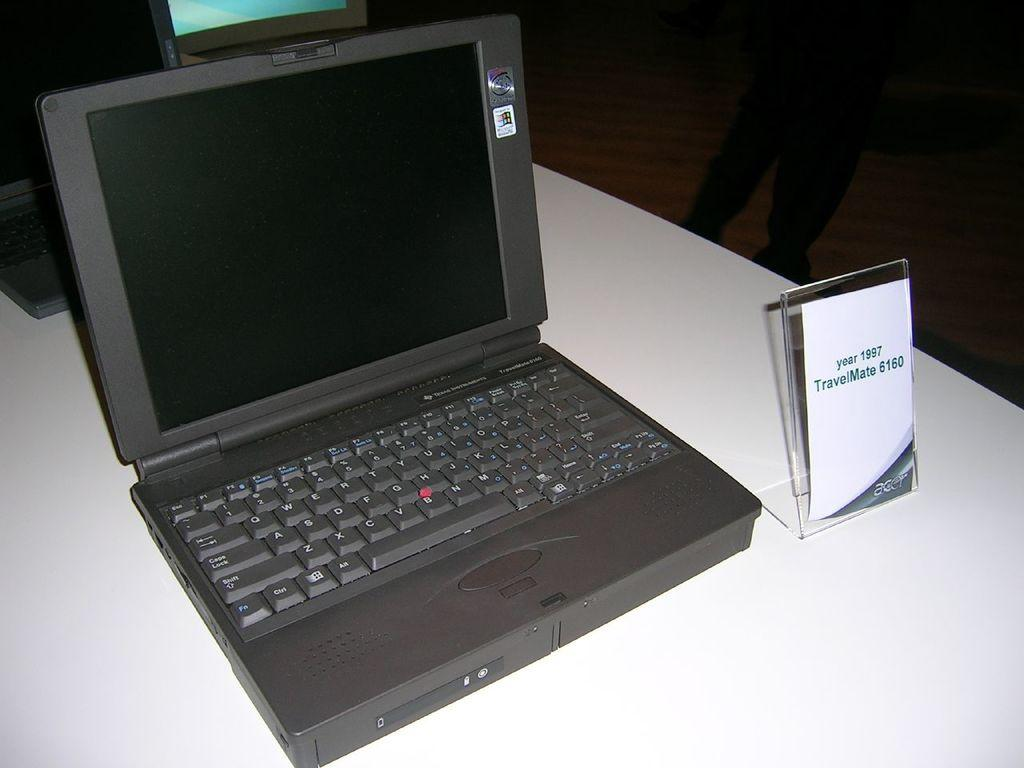<image>
Describe the image concisely. An Acer brand laptop is sitting on a counter with a brochure next to it and reads year 1997 TravelMate 6160. 